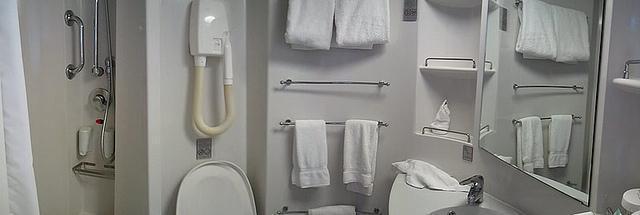How many towels are in this scene?
Give a very brief answer. 5. How many laptops are there?
Give a very brief answer. 0. 